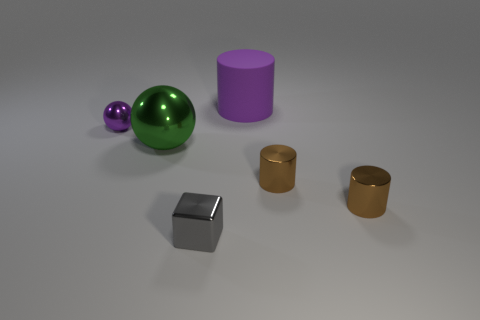Subtract all big matte cylinders. How many cylinders are left? 2 Subtract all gray balls. How many brown cylinders are left? 2 Add 2 purple metallic balls. How many objects exist? 8 Subtract all cubes. How many objects are left? 5 Subtract 1 brown cylinders. How many objects are left? 5 Subtract all small brown metal cylinders. Subtract all small metal balls. How many objects are left? 3 Add 3 tiny brown objects. How many tiny brown objects are left? 5 Add 3 large yellow cylinders. How many large yellow cylinders exist? 3 